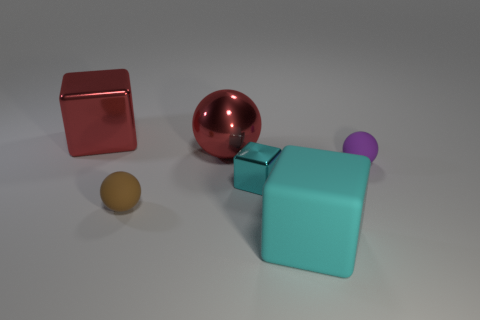Subtract all cyan spheres. How many cyan cubes are left? 2 Add 2 gray metallic blocks. How many objects exist? 8 Subtract all large red metal blocks. How many blocks are left? 2 Add 1 red shiny spheres. How many red shiny spheres are left? 2 Add 5 tiny purple metal cylinders. How many tiny purple metal cylinders exist? 5 Subtract 0 blue blocks. How many objects are left? 6 Subtract all metallic objects. Subtract all red matte things. How many objects are left? 3 